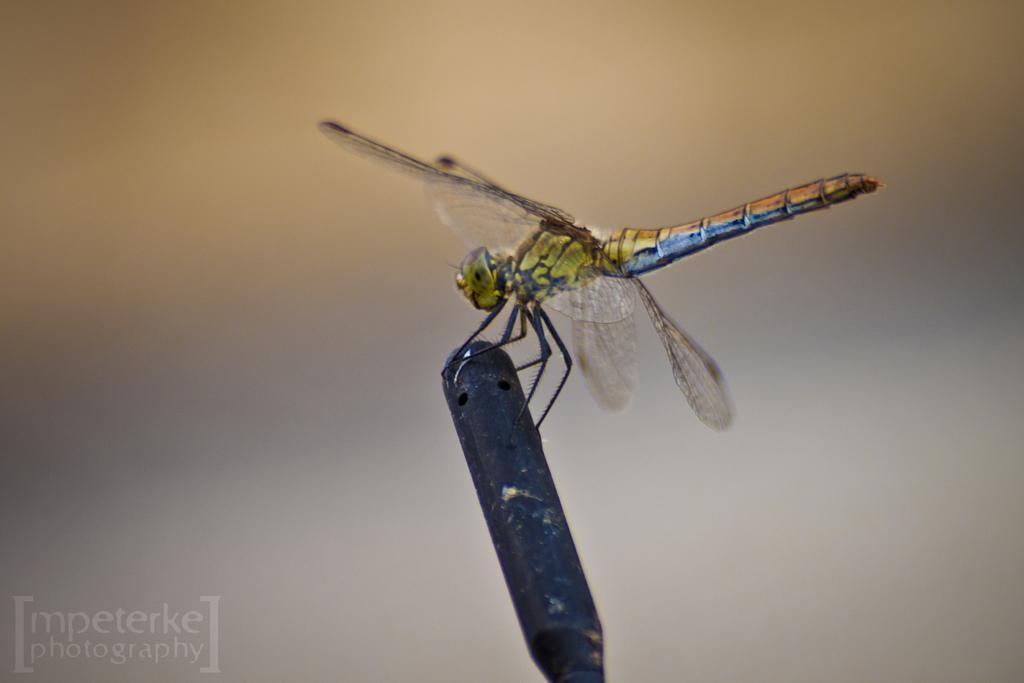Could you give a brief overview of what you see in this image? In this image in the center there is one insect, at the bottom there is some object and there is some text. 